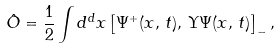Convert formula to latex. <formula><loc_0><loc_0><loc_500><loc_500>\hat { O } = \frac { 1 } { 2 } \int d ^ { d } x \left [ \Psi ^ { + } ( { x } , \, t ) , \, \Upsilon \Psi ( { x } , \, t ) \right ] _ { - } ,</formula> 